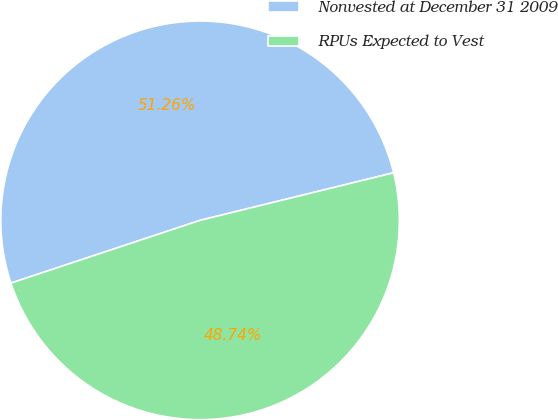Convert chart. <chart><loc_0><loc_0><loc_500><loc_500><pie_chart><fcel>Nonvested at December 31 2009<fcel>RPUs Expected to Vest<nl><fcel>51.26%<fcel>48.74%<nl></chart> 